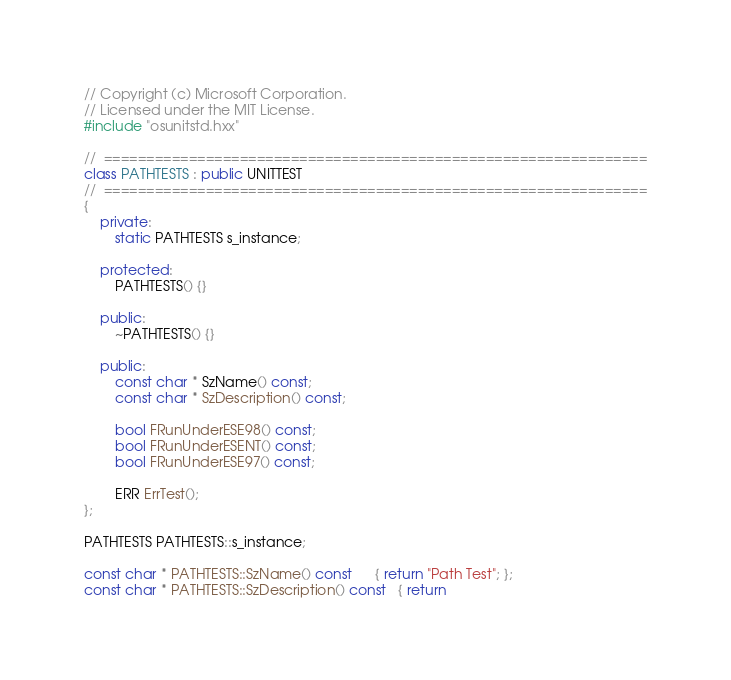Convert code to text. <code><loc_0><loc_0><loc_500><loc_500><_C++_>// Copyright (c) Microsoft Corporation.
// Licensed under the MIT License.
#include "osunitstd.hxx"

//  ================================================================
class PATHTESTS : public UNITTEST
//  ================================================================
{
    private:
        static PATHTESTS s_instance;

    protected:
        PATHTESTS() {}

    public:
        ~PATHTESTS() {}

    public:
        const char * SzName() const;
        const char * SzDescription() const;

        bool FRunUnderESE98() const;
        bool FRunUnderESENT() const;
        bool FRunUnderESE97() const;

        ERR ErrTest();
};

PATHTESTS PATHTESTS::s_instance;

const char * PATHTESTS::SzName() const      { return "Path Test"; };
const char * PATHTESTS::SzDescription() const   { return </code> 